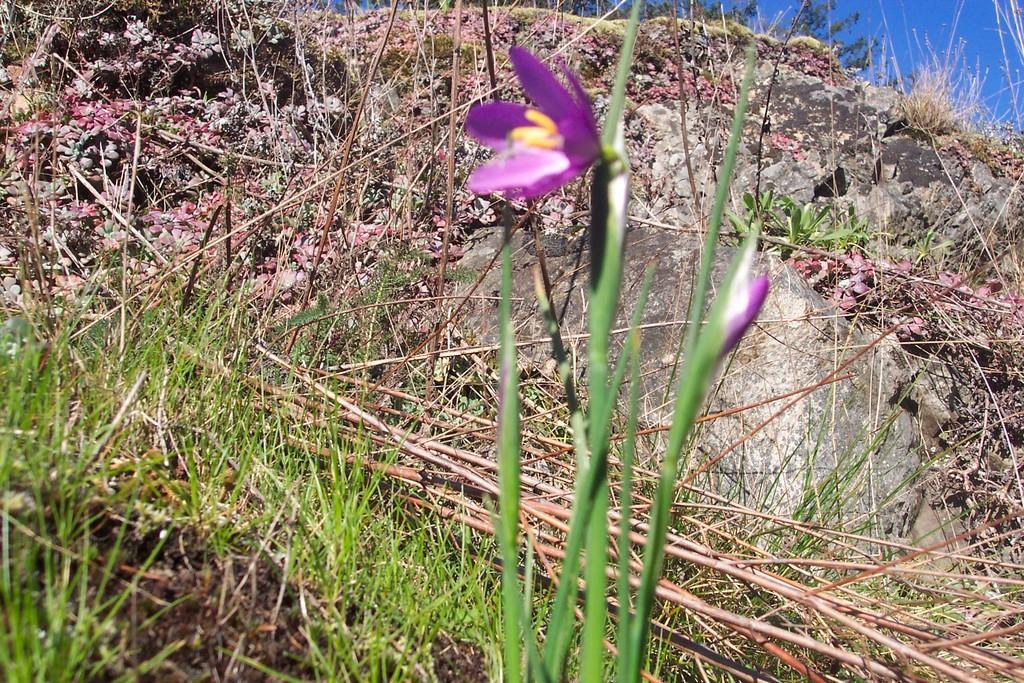In one or two sentences, can you explain what this image depicts? This picture is clicked outside. In the foreground we can see the plants and the grass. In the background there is a sky and the rocks. 